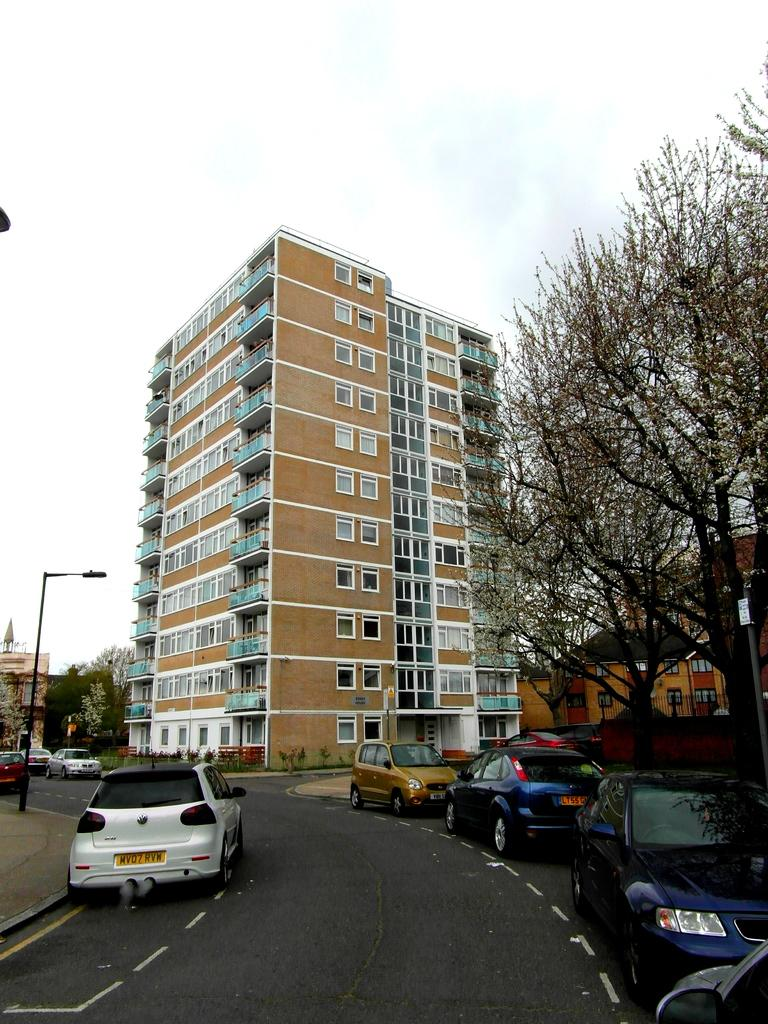What type of structures can be seen in the image? There are buildings in the image. What other natural elements are present in the image? There are trees in the image. Where is the pole located in the image? The pole is on the left side of the image. What type of vehicles can be seen on the road in the image? Cars are visible on the road at the bottom of the image. What is visible in the background of the image? There is sky visible in the background of the image. How many songs can be heard playing from the buildings in the image? There is no information about songs playing in the image, as it only shows buildings, trees, a pole, cars, and sky. What type of grip is required to hold the pole in the image? There is no need to grip the pole in the image, as it is a stationary object. 